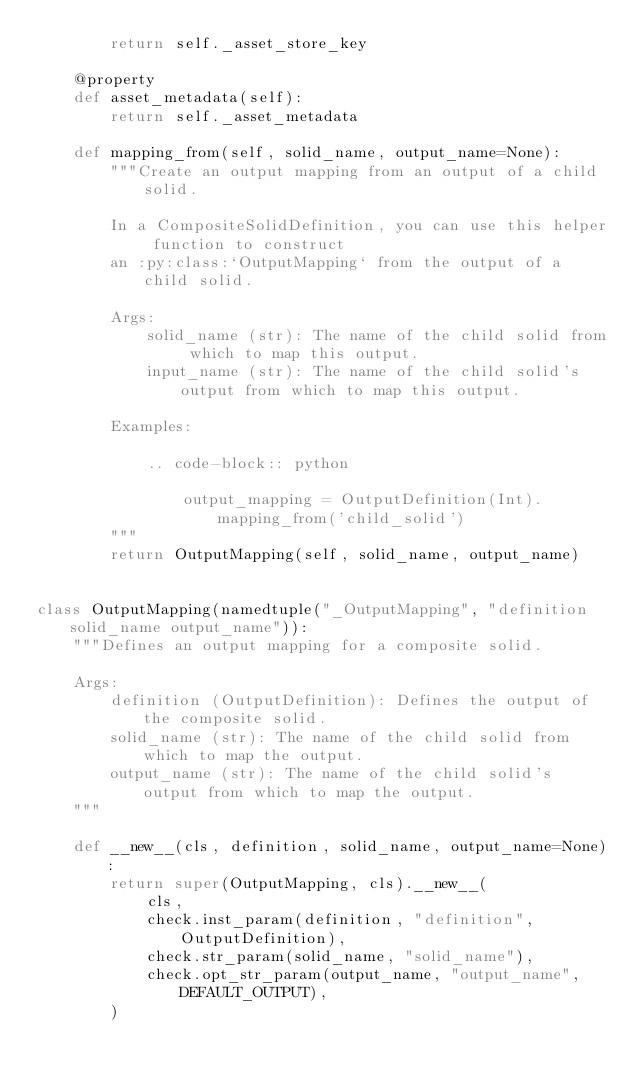Convert code to text. <code><loc_0><loc_0><loc_500><loc_500><_Python_>        return self._asset_store_key

    @property
    def asset_metadata(self):
        return self._asset_metadata

    def mapping_from(self, solid_name, output_name=None):
        """Create an output mapping from an output of a child solid.

        In a CompositeSolidDefinition, you can use this helper function to construct
        an :py:class:`OutputMapping` from the output of a child solid.

        Args:
            solid_name (str): The name of the child solid from which to map this output.
            input_name (str): The name of the child solid's output from which to map this output.

        Examples:

            .. code-block:: python

                output_mapping = OutputDefinition(Int).mapping_from('child_solid')
        """
        return OutputMapping(self, solid_name, output_name)


class OutputMapping(namedtuple("_OutputMapping", "definition solid_name output_name")):
    """Defines an output mapping for a composite solid.

    Args:
        definition (OutputDefinition): Defines the output of the composite solid.
        solid_name (str): The name of the child solid from which to map the output.
        output_name (str): The name of the child solid's output from which to map the output.
    """

    def __new__(cls, definition, solid_name, output_name=None):
        return super(OutputMapping, cls).__new__(
            cls,
            check.inst_param(definition, "definition", OutputDefinition),
            check.str_param(solid_name, "solid_name"),
            check.opt_str_param(output_name, "output_name", DEFAULT_OUTPUT),
        )
</code> 